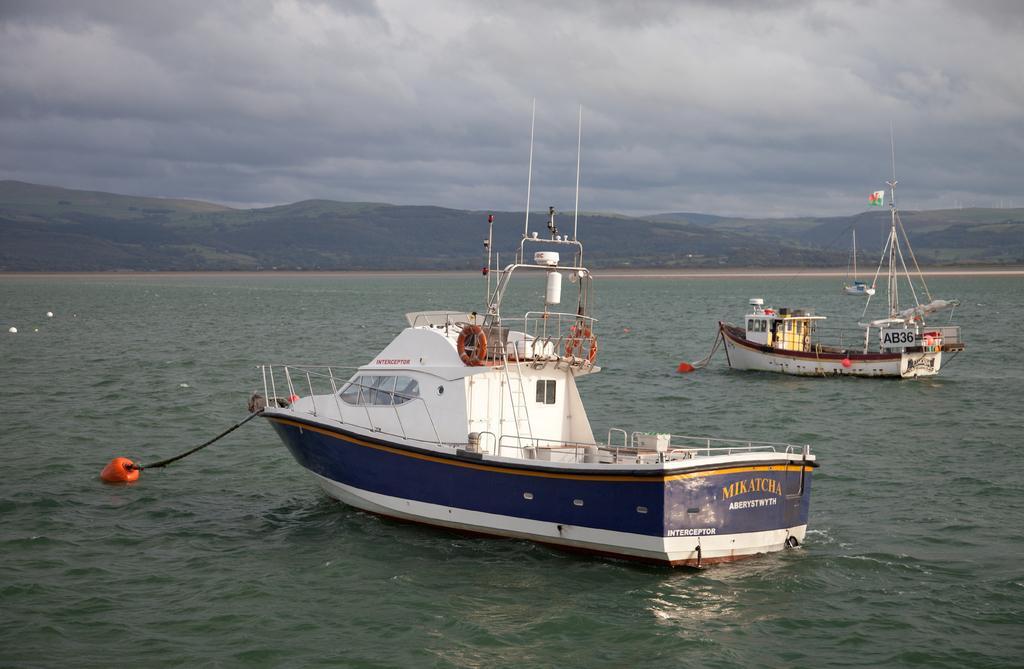How would you summarize this image in a sentence or two? This image is clicked in an ocean. And there are two boats in this image. In the background, there is a mountain. At the top, there are clouds in the sky. 